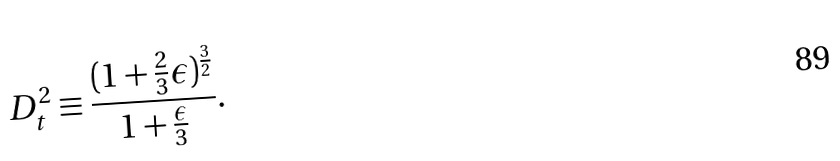Convert formula to latex. <formula><loc_0><loc_0><loc_500><loc_500>D ^ { 2 } _ { t } \equiv \frac { ( 1 + \frac { 2 } { 3 } \epsilon ) ^ { \frac { 3 } { 2 } } } { 1 + \frac { \epsilon } { 3 } } .</formula> 